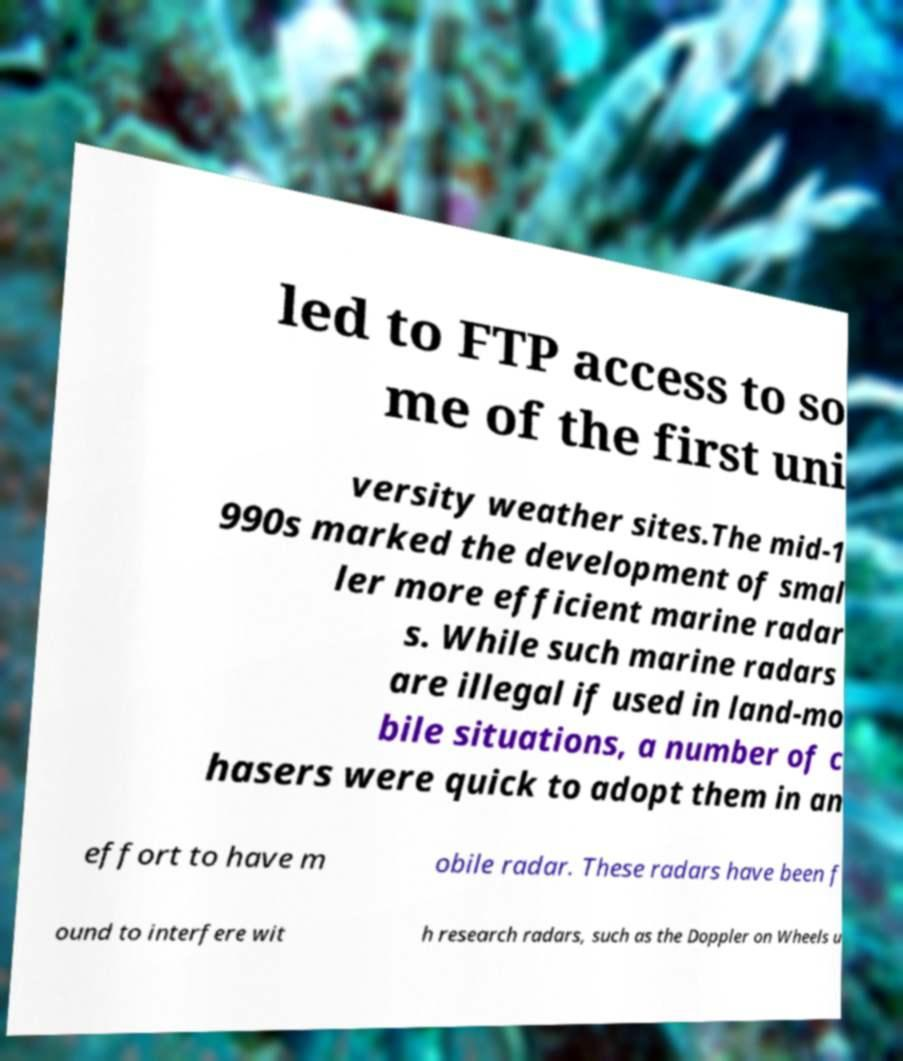What messages or text are displayed in this image? I need them in a readable, typed format. led to FTP access to so me of the first uni versity weather sites.The mid-1 990s marked the development of smal ler more efficient marine radar s. While such marine radars are illegal if used in land-mo bile situations, a number of c hasers were quick to adopt them in an effort to have m obile radar. These radars have been f ound to interfere wit h research radars, such as the Doppler on Wheels u 